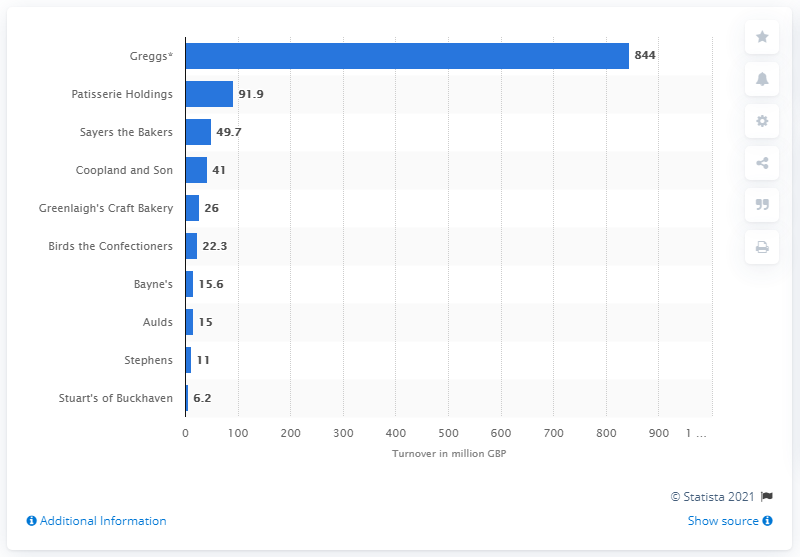List a handful of essential elements in this visual. According to an estimate by Greggs in 2016, their turnover was approximately £844 million. 